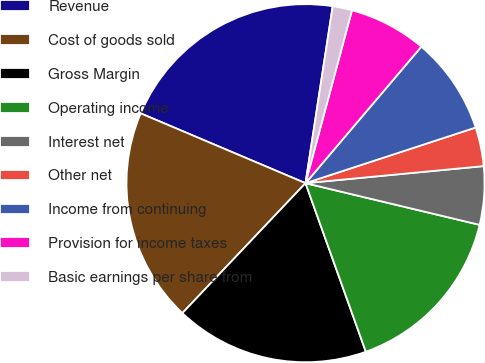Convert chart. <chart><loc_0><loc_0><loc_500><loc_500><pie_chart><fcel>Revenue<fcel>Cost of goods sold<fcel>Gross Margin<fcel>Operating income<fcel>Interest net<fcel>Other net<fcel>Income from continuing<fcel>Provision for income taxes<fcel>Basic earnings per share from<nl><fcel>21.05%<fcel>19.3%<fcel>17.54%<fcel>15.79%<fcel>5.26%<fcel>3.51%<fcel>8.77%<fcel>7.02%<fcel>1.75%<nl></chart> 